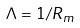<formula> <loc_0><loc_0><loc_500><loc_500>\Lambda = 1 / R _ { m }</formula> 